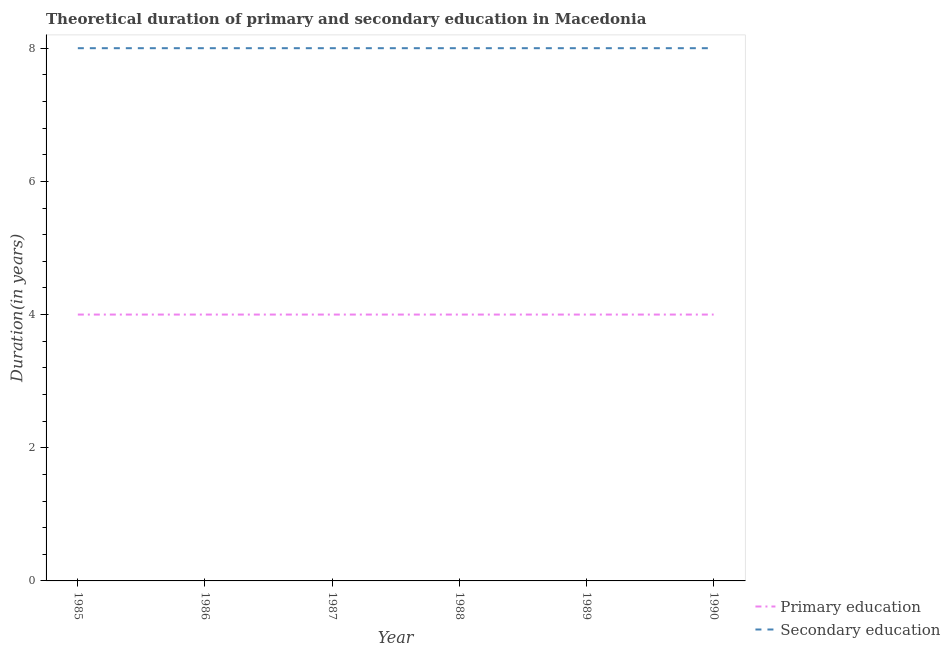How many different coloured lines are there?
Make the answer very short. 2. Does the line corresponding to duration of primary education intersect with the line corresponding to duration of secondary education?
Offer a terse response. No. What is the duration of primary education in 1989?
Give a very brief answer. 4. Across all years, what is the maximum duration of primary education?
Your answer should be compact. 4. Across all years, what is the minimum duration of secondary education?
Your answer should be very brief. 8. In which year was the duration of secondary education maximum?
Make the answer very short. 1985. What is the total duration of primary education in the graph?
Your answer should be very brief. 24. What is the difference between the duration of primary education in 1989 and the duration of secondary education in 1988?
Ensure brevity in your answer.  -4. In the year 1986, what is the difference between the duration of primary education and duration of secondary education?
Your response must be concise. -4. In how many years, is the duration of secondary education greater than 2 years?
Your answer should be very brief. 6. What is the ratio of the duration of primary education in 1988 to that in 1989?
Ensure brevity in your answer.  1. Is the duration of secondary education in 1985 less than that in 1987?
Your response must be concise. No. Is the difference between the duration of primary education in 1985 and 1986 greater than the difference between the duration of secondary education in 1985 and 1986?
Offer a terse response. No. What is the difference between the highest and the second highest duration of primary education?
Your response must be concise. 0. What is the difference between the highest and the lowest duration of primary education?
Keep it short and to the point. 0. Is the sum of the duration of secondary education in 1987 and 1989 greater than the maximum duration of primary education across all years?
Offer a terse response. Yes. Is the duration of primary education strictly greater than the duration of secondary education over the years?
Your response must be concise. No. How many lines are there?
Provide a short and direct response. 2. What is the difference between two consecutive major ticks on the Y-axis?
Keep it short and to the point. 2. Does the graph contain any zero values?
Keep it short and to the point. No. Does the graph contain grids?
Your answer should be very brief. No. Where does the legend appear in the graph?
Offer a very short reply. Bottom right. What is the title of the graph?
Provide a short and direct response. Theoretical duration of primary and secondary education in Macedonia. What is the label or title of the Y-axis?
Ensure brevity in your answer.  Duration(in years). What is the Duration(in years) in Primary education in 1985?
Offer a very short reply. 4. What is the Duration(in years) of Secondary education in 1985?
Provide a short and direct response. 8. What is the Duration(in years) of Primary education in 1986?
Give a very brief answer. 4. What is the Duration(in years) in Primary education in 1987?
Offer a very short reply. 4. What is the Duration(in years) of Secondary education in 1987?
Make the answer very short. 8. What is the Duration(in years) of Primary education in 1988?
Ensure brevity in your answer.  4. What is the Duration(in years) of Primary education in 1990?
Your response must be concise. 4. Across all years, what is the maximum Duration(in years) in Secondary education?
Your answer should be very brief. 8. Across all years, what is the minimum Duration(in years) in Secondary education?
Ensure brevity in your answer.  8. What is the total Duration(in years) in Secondary education in the graph?
Give a very brief answer. 48. What is the difference between the Duration(in years) in Secondary education in 1985 and that in 1986?
Give a very brief answer. 0. What is the difference between the Duration(in years) in Primary education in 1985 and that in 1987?
Provide a short and direct response. 0. What is the difference between the Duration(in years) in Primary education in 1985 and that in 1988?
Offer a very short reply. 0. What is the difference between the Duration(in years) of Primary education in 1985 and that in 1989?
Provide a short and direct response. 0. What is the difference between the Duration(in years) in Primary education in 1985 and that in 1990?
Provide a short and direct response. 0. What is the difference between the Duration(in years) in Secondary education in 1986 and that in 1987?
Offer a very short reply. 0. What is the difference between the Duration(in years) of Primary education in 1986 and that in 1988?
Your answer should be compact. 0. What is the difference between the Duration(in years) of Secondary education in 1986 and that in 1988?
Your answer should be compact. 0. What is the difference between the Duration(in years) of Secondary education in 1986 and that in 1989?
Offer a very short reply. 0. What is the difference between the Duration(in years) of Secondary education in 1986 and that in 1990?
Your answer should be very brief. 0. What is the difference between the Duration(in years) in Primary education in 1987 and that in 1988?
Provide a succinct answer. 0. What is the difference between the Duration(in years) of Primary education in 1987 and that in 1989?
Your answer should be very brief. 0. What is the difference between the Duration(in years) of Secondary education in 1987 and that in 1989?
Make the answer very short. 0. What is the difference between the Duration(in years) in Secondary education in 1987 and that in 1990?
Make the answer very short. 0. What is the difference between the Duration(in years) of Primary education in 1988 and that in 1990?
Offer a very short reply. 0. What is the difference between the Duration(in years) in Primary education in 1989 and that in 1990?
Provide a succinct answer. 0. What is the difference between the Duration(in years) of Secondary education in 1989 and that in 1990?
Give a very brief answer. 0. What is the difference between the Duration(in years) of Primary education in 1985 and the Duration(in years) of Secondary education in 1987?
Provide a succinct answer. -4. What is the difference between the Duration(in years) of Primary education in 1985 and the Duration(in years) of Secondary education in 1990?
Offer a very short reply. -4. What is the difference between the Duration(in years) in Primary education in 1986 and the Duration(in years) in Secondary education in 1989?
Provide a short and direct response. -4. What is the difference between the Duration(in years) of Primary education in 1986 and the Duration(in years) of Secondary education in 1990?
Keep it short and to the point. -4. What is the difference between the Duration(in years) in Primary education in 1987 and the Duration(in years) in Secondary education in 1988?
Make the answer very short. -4. What is the average Duration(in years) of Primary education per year?
Ensure brevity in your answer.  4. What is the average Duration(in years) in Secondary education per year?
Keep it short and to the point. 8. In the year 1985, what is the difference between the Duration(in years) of Primary education and Duration(in years) of Secondary education?
Keep it short and to the point. -4. In the year 1987, what is the difference between the Duration(in years) of Primary education and Duration(in years) of Secondary education?
Ensure brevity in your answer.  -4. In the year 1988, what is the difference between the Duration(in years) of Primary education and Duration(in years) of Secondary education?
Your answer should be very brief. -4. What is the ratio of the Duration(in years) of Secondary education in 1985 to that in 1988?
Give a very brief answer. 1. What is the ratio of the Duration(in years) in Secondary education in 1985 to that in 1989?
Provide a succinct answer. 1. What is the ratio of the Duration(in years) of Secondary education in 1985 to that in 1990?
Provide a short and direct response. 1. What is the ratio of the Duration(in years) of Primary education in 1986 to that in 1987?
Your response must be concise. 1. What is the ratio of the Duration(in years) of Primary education in 1986 to that in 1988?
Keep it short and to the point. 1. What is the ratio of the Duration(in years) of Secondary education in 1986 to that in 1988?
Make the answer very short. 1. What is the ratio of the Duration(in years) in Primary education in 1986 to that in 1989?
Your answer should be very brief. 1. What is the ratio of the Duration(in years) of Secondary education in 1986 to that in 1989?
Your answer should be compact. 1. What is the ratio of the Duration(in years) of Secondary education in 1986 to that in 1990?
Your answer should be compact. 1. What is the ratio of the Duration(in years) of Primary education in 1987 to that in 1988?
Your response must be concise. 1. What is the ratio of the Duration(in years) of Secondary education in 1987 to that in 1988?
Provide a short and direct response. 1. What is the ratio of the Duration(in years) of Primary education in 1987 to that in 1989?
Your response must be concise. 1. What is the ratio of the Duration(in years) of Secondary education in 1987 to that in 1989?
Ensure brevity in your answer.  1. What is the ratio of the Duration(in years) of Primary education in 1987 to that in 1990?
Provide a short and direct response. 1. What is the ratio of the Duration(in years) in Secondary education in 1988 to that in 1989?
Offer a terse response. 1. What is the ratio of the Duration(in years) of Primary education in 1988 to that in 1990?
Make the answer very short. 1. What is the ratio of the Duration(in years) of Secondary education in 1989 to that in 1990?
Provide a succinct answer. 1. What is the difference between the highest and the second highest Duration(in years) of Primary education?
Provide a short and direct response. 0. What is the difference between the highest and the lowest Duration(in years) in Primary education?
Provide a short and direct response. 0. 